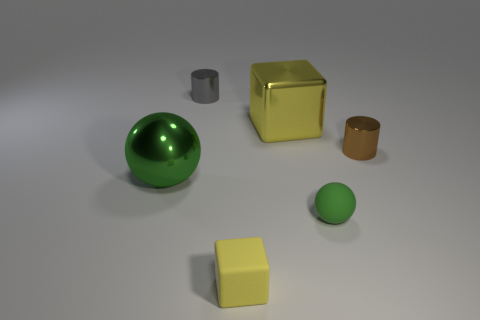What number of other things are there of the same color as the matte sphere?
Your response must be concise. 1. What is the material of the large green object?
Offer a terse response. Metal. There is a small object that is both left of the green matte sphere and behind the small cube; what material is it?
Your answer should be compact. Metal. What number of objects are objects that are on the left side of the brown shiny object or cyan shiny things?
Make the answer very short. 5. Is the matte ball the same color as the shiny sphere?
Give a very brief answer. Yes. Is there a metal thing of the same size as the green metal ball?
Your answer should be compact. Yes. What number of big things are behind the green metallic sphere and in front of the yellow shiny cube?
Make the answer very short. 0. There is a small yellow block; how many big yellow blocks are left of it?
Make the answer very short. 0. Is there a small gray thing that has the same shape as the large green object?
Give a very brief answer. No. Do the tiny gray thing and the matte thing that is behind the matte block have the same shape?
Offer a very short reply. No. 